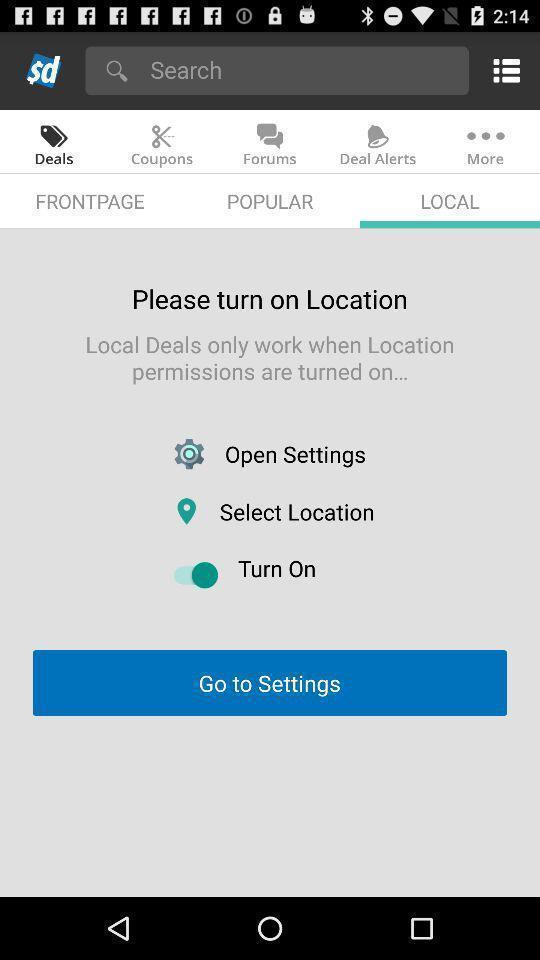What details can you identify in this image? Page showing to turn on location for getting information. 